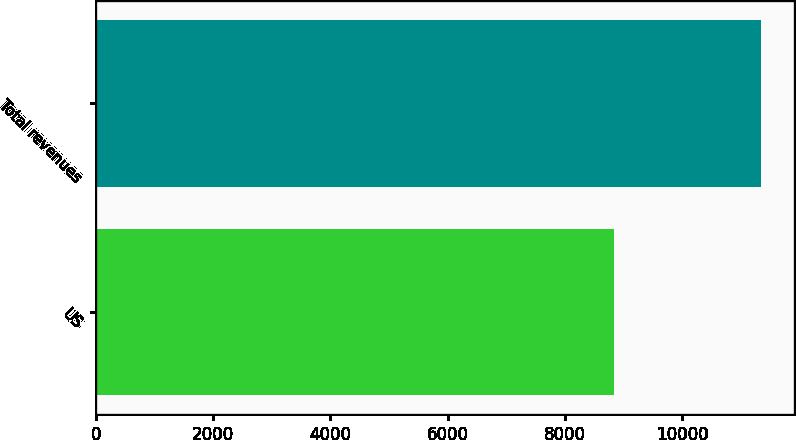Convert chart to OTSL. <chart><loc_0><loc_0><loc_500><loc_500><bar_chart><fcel>US<fcel>Total revenues<nl><fcel>8843.5<fcel>11333.4<nl></chart> 